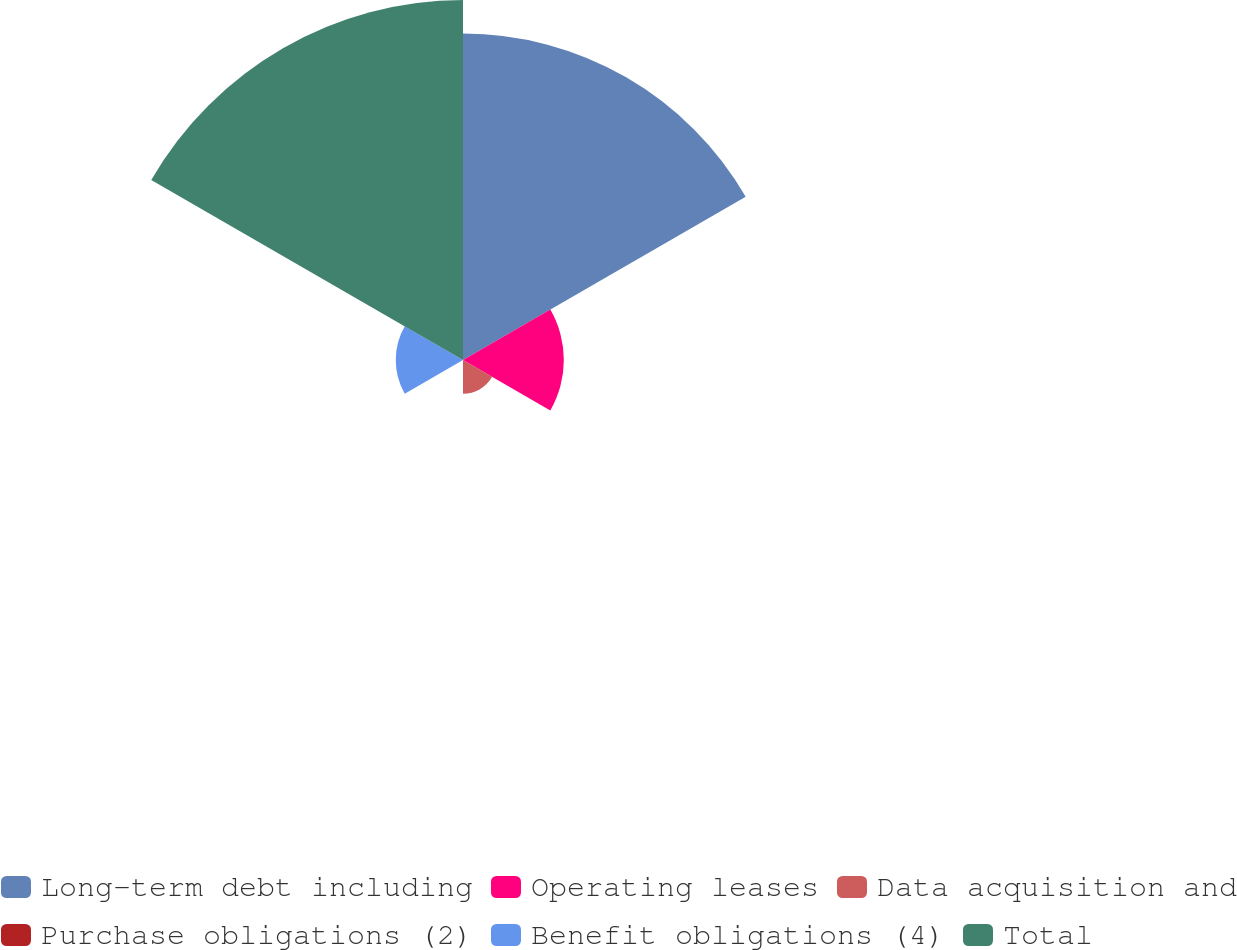Convert chart. <chart><loc_0><loc_0><loc_500><loc_500><pie_chart><fcel>Long-term debt including<fcel>Operating leases<fcel>Data acquisition and<fcel>Purchase obligations (2)<fcel>Benefit obligations (4)<fcel>Total<nl><fcel>36.74%<fcel>11.35%<fcel>3.79%<fcel>0.01%<fcel>7.57%<fcel>40.52%<nl></chart> 